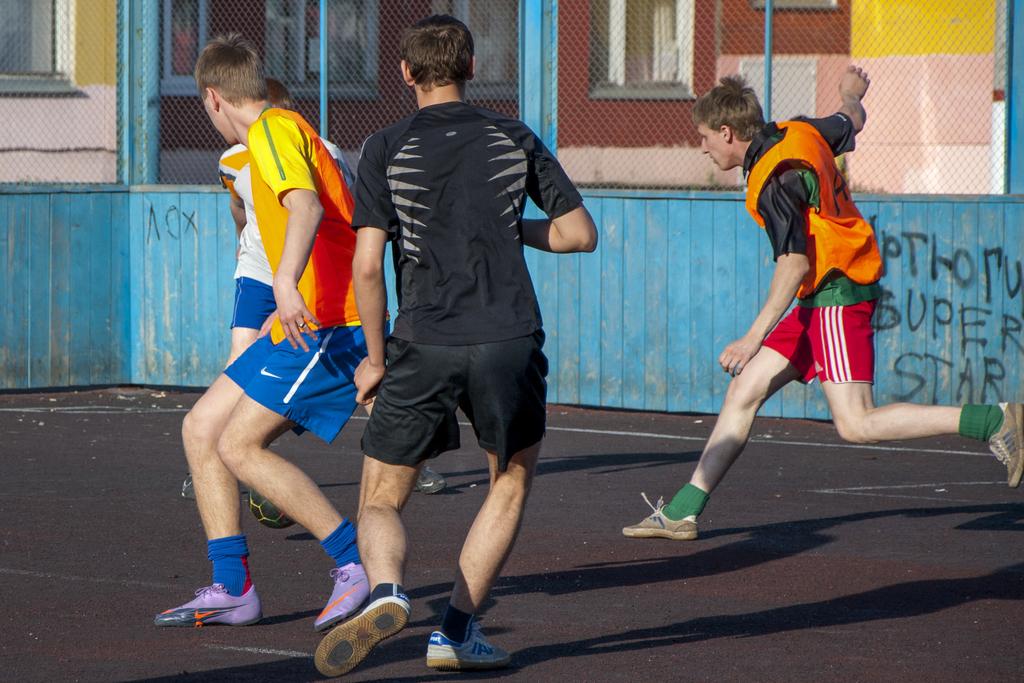What are the last two words written on the wall on the right?
Ensure brevity in your answer.  Super star. 